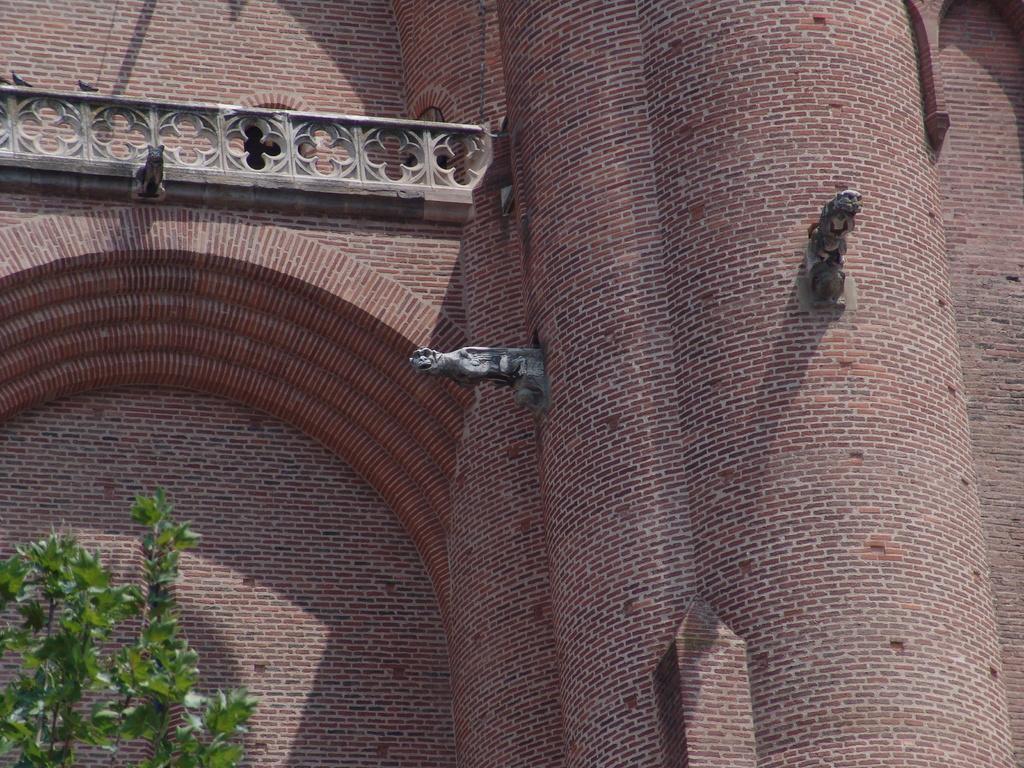Could you give a brief overview of what you see in this image? This picture shows a building and we see a tree. 